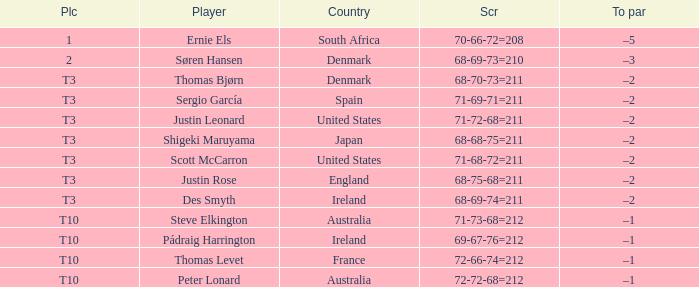What was the score for Peter Lonard? 72-72-68=212. 